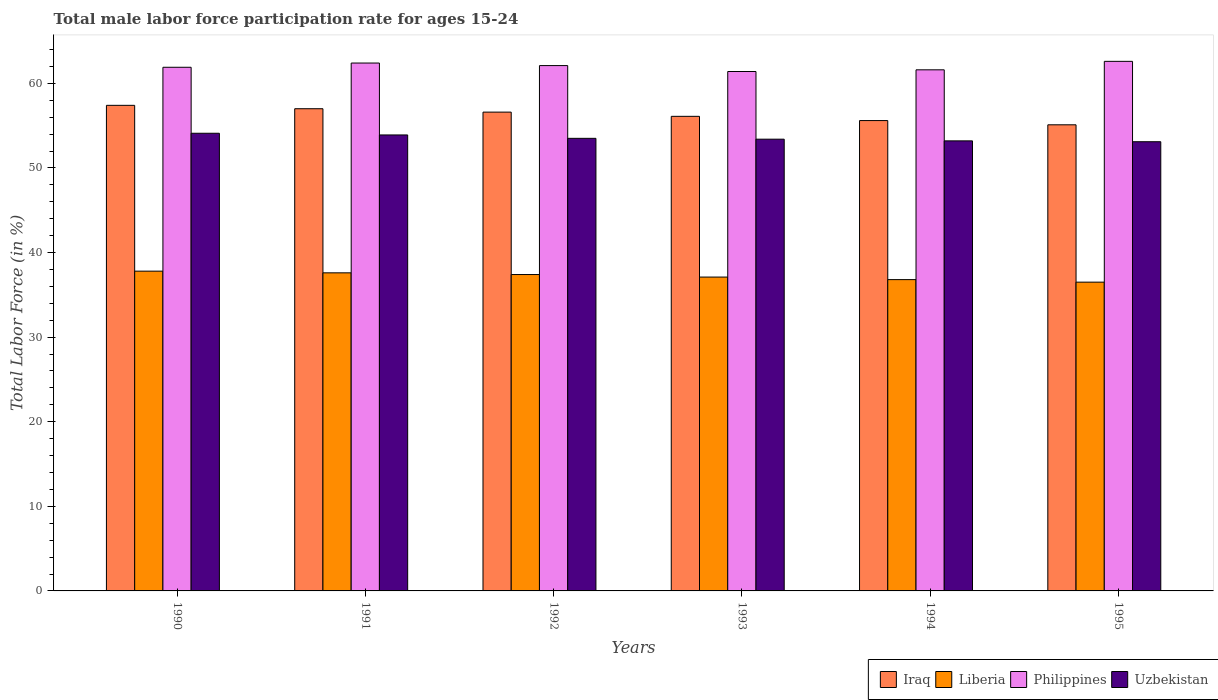How many different coloured bars are there?
Provide a short and direct response. 4. How many groups of bars are there?
Give a very brief answer. 6. Are the number of bars per tick equal to the number of legend labels?
Offer a very short reply. Yes. Are the number of bars on each tick of the X-axis equal?
Ensure brevity in your answer.  Yes. How many bars are there on the 6th tick from the left?
Your answer should be compact. 4. What is the label of the 3rd group of bars from the left?
Provide a succinct answer. 1992. In how many cases, is the number of bars for a given year not equal to the number of legend labels?
Ensure brevity in your answer.  0. Across all years, what is the maximum male labor force participation rate in Philippines?
Your answer should be very brief. 62.6. Across all years, what is the minimum male labor force participation rate in Liberia?
Offer a terse response. 36.5. What is the total male labor force participation rate in Philippines in the graph?
Provide a short and direct response. 372. What is the difference between the male labor force participation rate in Iraq in 1991 and that in 1992?
Provide a succinct answer. 0.4. What is the average male labor force participation rate in Uzbekistan per year?
Your answer should be very brief. 53.53. In the year 1991, what is the difference between the male labor force participation rate in Iraq and male labor force participation rate in Liberia?
Make the answer very short. 19.4. In how many years, is the male labor force participation rate in Uzbekistan greater than 56 %?
Provide a short and direct response. 0. What is the ratio of the male labor force participation rate in Iraq in 1994 to that in 1995?
Keep it short and to the point. 1.01. Is the male labor force participation rate in Iraq in 1990 less than that in 1991?
Provide a short and direct response. No. What is the difference between the highest and the second highest male labor force participation rate in Uzbekistan?
Make the answer very short. 0.2. What is the difference between the highest and the lowest male labor force participation rate in Iraq?
Provide a short and direct response. 2.3. In how many years, is the male labor force participation rate in Uzbekistan greater than the average male labor force participation rate in Uzbekistan taken over all years?
Give a very brief answer. 2. Is it the case that in every year, the sum of the male labor force participation rate in Iraq and male labor force participation rate in Philippines is greater than the sum of male labor force participation rate in Uzbekistan and male labor force participation rate in Liberia?
Provide a succinct answer. Yes. What does the 3rd bar from the left in 1991 represents?
Your answer should be compact. Philippines. What does the 2nd bar from the right in 1995 represents?
Provide a short and direct response. Philippines. How many bars are there?
Offer a very short reply. 24. Are all the bars in the graph horizontal?
Your response must be concise. No. Are the values on the major ticks of Y-axis written in scientific E-notation?
Provide a short and direct response. No. Where does the legend appear in the graph?
Ensure brevity in your answer.  Bottom right. How many legend labels are there?
Offer a terse response. 4. How are the legend labels stacked?
Your response must be concise. Horizontal. What is the title of the graph?
Offer a very short reply. Total male labor force participation rate for ages 15-24. Does "South Africa" appear as one of the legend labels in the graph?
Your response must be concise. No. What is the Total Labor Force (in %) of Iraq in 1990?
Give a very brief answer. 57.4. What is the Total Labor Force (in %) of Liberia in 1990?
Your answer should be very brief. 37.8. What is the Total Labor Force (in %) in Philippines in 1990?
Your answer should be very brief. 61.9. What is the Total Labor Force (in %) of Uzbekistan in 1990?
Make the answer very short. 54.1. What is the Total Labor Force (in %) of Iraq in 1991?
Make the answer very short. 57. What is the Total Labor Force (in %) in Liberia in 1991?
Your answer should be very brief. 37.6. What is the Total Labor Force (in %) in Philippines in 1991?
Make the answer very short. 62.4. What is the Total Labor Force (in %) in Uzbekistan in 1991?
Offer a terse response. 53.9. What is the Total Labor Force (in %) of Iraq in 1992?
Your answer should be very brief. 56.6. What is the Total Labor Force (in %) of Liberia in 1992?
Keep it short and to the point. 37.4. What is the Total Labor Force (in %) in Philippines in 1992?
Provide a short and direct response. 62.1. What is the Total Labor Force (in %) of Uzbekistan in 1992?
Your answer should be compact. 53.5. What is the Total Labor Force (in %) of Iraq in 1993?
Give a very brief answer. 56.1. What is the Total Labor Force (in %) of Liberia in 1993?
Provide a short and direct response. 37.1. What is the Total Labor Force (in %) of Philippines in 1993?
Keep it short and to the point. 61.4. What is the Total Labor Force (in %) in Uzbekistan in 1993?
Your answer should be very brief. 53.4. What is the Total Labor Force (in %) in Iraq in 1994?
Ensure brevity in your answer.  55.6. What is the Total Labor Force (in %) of Liberia in 1994?
Your answer should be compact. 36.8. What is the Total Labor Force (in %) of Philippines in 1994?
Your response must be concise. 61.6. What is the Total Labor Force (in %) of Uzbekistan in 1994?
Ensure brevity in your answer.  53.2. What is the Total Labor Force (in %) in Iraq in 1995?
Provide a short and direct response. 55.1. What is the Total Labor Force (in %) of Liberia in 1995?
Your answer should be compact. 36.5. What is the Total Labor Force (in %) of Philippines in 1995?
Provide a succinct answer. 62.6. What is the Total Labor Force (in %) of Uzbekistan in 1995?
Your answer should be very brief. 53.1. Across all years, what is the maximum Total Labor Force (in %) of Iraq?
Offer a very short reply. 57.4. Across all years, what is the maximum Total Labor Force (in %) in Liberia?
Your answer should be very brief. 37.8. Across all years, what is the maximum Total Labor Force (in %) in Philippines?
Keep it short and to the point. 62.6. Across all years, what is the maximum Total Labor Force (in %) of Uzbekistan?
Your answer should be very brief. 54.1. Across all years, what is the minimum Total Labor Force (in %) in Iraq?
Provide a succinct answer. 55.1. Across all years, what is the minimum Total Labor Force (in %) of Liberia?
Your response must be concise. 36.5. Across all years, what is the minimum Total Labor Force (in %) in Philippines?
Your response must be concise. 61.4. Across all years, what is the minimum Total Labor Force (in %) of Uzbekistan?
Your answer should be compact. 53.1. What is the total Total Labor Force (in %) in Iraq in the graph?
Offer a very short reply. 337.8. What is the total Total Labor Force (in %) of Liberia in the graph?
Ensure brevity in your answer.  223.2. What is the total Total Labor Force (in %) of Philippines in the graph?
Your answer should be very brief. 372. What is the total Total Labor Force (in %) in Uzbekistan in the graph?
Provide a succinct answer. 321.2. What is the difference between the Total Labor Force (in %) in Iraq in 1990 and that in 1991?
Your response must be concise. 0.4. What is the difference between the Total Labor Force (in %) in Iraq in 1990 and that in 1992?
Your answer should be compact. 0.8. What is the difference between the Total Labor Force (in %) in Liberia in 1990 and that in 1992?
Give a very brief answer. 0.4. What is the difference between the Total Labor Force (in %) in Iraq in 1990 and that in 1993?
Your response must be concise. 1.3. What is the difference between the Total Labor Force (in %) in Liberia in 1990 and that in 1993?
Provide a succinct answer. 0.7. What is the difference between the Total Labor Force (in %) of Iraq in 1990 and that in 1994?
Offer a very short reply. 1.8. What is the difference between the Total Labor Force (in %) in Philippines in 1990 and that in 1994?
Provide a succinct answer. 0.3. What is the difference between the Total Labor Force (in %) in Uzbekistan in 1990 and that in 1994?
Your answer should be compact. 0.9. What is the difference between the Total Labor Force (in %) in Liberia in 1990 and that in 1995?
Provide a succinct answer. 1.3. What is the difference between the Total Labor Force (in %) of Uzbekistan in 1990 and that in 1995?
Your response must be concise. 1. What is the difference between the Total Labor Force (in %) in Iraq in 1991 and that in 1992?
Provide a succinct answer. 0.4. What is the difference between the Total Labor Force (in %) of Philippines in 1991 and that in 1992?
Give a very brief answer. 0.3. What is the difference between the Total Labor Force (in %) of Uzbekistan in 1991 and that in 1992?
Your answer should be compact. 0.4. What is the difference between the Total Labor Force (in %) in Iraq in 1991 and that in 1993?
Your answer should be compact. 0.9. What is the difference between the Total Labor Force (in %) in Philippines in 1991 and that in 1993?
Offer a terse response. 1. What is the difference between the Total Labor Force (in %) of Uzbekistan in 1991 and that in 1993?
Give a very brief answer. 0.5. What is the difference between the Total Labor Force (in %) of Liberia in 1991 and that in 1994?
Make the answer very short. 0.8. What is the difference between the Total Labor Force (in %) in Philippines in 1991 and that in 1994?
Offer a very short reply. 0.8. What is the difference between the Total Labor Force (in %) of Iraq in 1991 and that in 1995?
Keep it short and to the point. 1.9. What is the difference between the Total Labor Force (in %) in Philippines in 1991 and that in 1995?
Your answer should be very brief. -0.2. What is the difference between the Total Labor Force (in %) in Uzbekistan in 1991 and that in 1995?
Offer a terse response. 0.8. What is the difference between the Total Labor Force (in %) of Iraq in 1992 and that in 1993?
Provide a short and direct response. 0.5. What is the difference between the Total Labor Force (in %) in Liberia in 1992 and that in 1993?
Provide a succinct answer. 0.3. What is the difference between the Total Labor Force (in %) of Philippines in 1992 and that in 1993?
Ensure brevity in your answer.  0.7. What is the difference between the Total Labor Force (in %) of Liberia in 1992 and that in 1994?
Ensure brevity in your answer.  0.6. What is the difference between the Total Labor Force (in %) of Philippines in 1992 and that in 1994?
Your response must be concise. 0.5. What is the difference between the Total Labor Force (in %) in Uzbekistan in 1992 and that in 1994?
Provide a succinct answer. 0.3. What is the difference between the Total Labor Force (in %) in Iraq in 1992 and that in 1995?
Your answer should be compact. 1.5. What is the difference between the Total Labor Force (in %) in Philippines in 1992 and that in 1995?
Offer a terse response. -0.5. What is the difference between the Total Labor Force (in %) of Uzbekistan in 1992 and that in 1995?
Your response must be concise. 0.4. What is the difference between the Total Labor Force (in %) of Liberia in 1993 and that in 1994?
Your answer should be compact. 0.3. What is the difference between the Total Labor Force (in %) in Philippines in 1993 and that in 1994?
Your answer should be compact. -0.2. What is the difference between the Total Labor Force (in %) of Liberia in 1993 and that in 1995?
Offer a terse response. 0.6. What is the difference between the Total Labor Force (in %) of Uzbekistan in 1993 and that in 1995?
Make the answer very short. 0.3. What is the difference between the Total Labor Force (in %) of Liberia in 1994 and that in 1995?
Give a very brief answer. 0.3. What is the difference between the Total Labor Force (in %) of Uzbekistan in 1994 and that in 1995?
Offer a terse response. 0.1. What is the difference between the Total Labor Force (in %) of Iraq in 1990 and the Total Labor Force (in %) of Liberia in 1991?
Keep it short and to the point. 19.8. What is the difference between the Total Labor Force (in %) of Iraq in 1990 and the Total Labor Force (in %) of Uzbekistan in 1991?
Ensure brevity in your answer.  3.5. What is the difference between the Total Labor Force (in %) in Liberia in 1990 and the Total Labor Force (in %) in Philippines in 1991?
Ensure brevity in your answer.  -24.6. What is the difference between the Total Labor Force (in %) in Liberia in 1990 and the Total Labor Force (in %) in Uzbekistan in 1991?
Your answer should be very brief. -16.1. What is the difference between the Total Labor Force (in %) of Iraq in 1990 and the Total Labor Force (in %) of Liberia in 1992?
Provide a short and direct response. 20. What is the difference between the Total Labor Force (in %) in Iraq in 1990 and the Total Labor Force (in %) in Uzbekistan in 1992?
Make the answer very short. 3.9. What is the difference between the Total Labor Force (in %) of Liberia in 1990 and the Total Labor Force (in %) of Philippines in 1992?
Give a very brief answer. -24.3. What is the difference between the Total Labor Force (in %) of Liberia in 1990 and the Total Labor Force (in %) of Uzbekistan in 1992?
Make the answer very short. -15.7. What is the difference between the Total Labor Force (in %) of Philippines in 1990 and the Total Labor Force (in %) of Uzbekistan in 1992?
Offer a very short reply. 8.4. What is the difference between the Total Labor Force (in %) of Iraq in 1990 and the Total Labor Force (in %) of Liberia in 1993?
Provide a short and direct response. 20.3. What is the difference between the Total Labor Force (in %) in Iraq in 1990 and the Total Labor Force (in %) in Philippines in 1993?
Make the answer very short. -4. What is the difference between the Total Labor Force (in %) in Iraq in 1990 and the Total Labor Force (in %) in Uzbekistan in 1993?
Your answer should be compact. 4. What is the difference between the Total Labor Force (in %) in Liberia in 1990 and the Total Labor Force (in %) in Philippines in 1993?
Your answer should be compact. -23.6. What is the difference between the Total Labor Force (in %) of Liberia in 1990 and the Total Labor Force (in %) of Uzbekistan in 1993?
Offer a very short reply. -15.6. What is the difference between the Total Labor Force (in %) of Iraq in 1990 and the Total Labor Force (in %) of Liberia in 1994?
Your answer should be very brief. 20.6. What is the difference between the Total Labor Force (in %) in Liberia in 1990 and the Total Labor Force (in %) in Philippines in 1994?
Your answer should be compact. -23.8. What is the difference between the Total Labor Force (in %) of Liberia in 1990 and the Total Labor Force (in %) of Uzbekistan in 1994?
Make the answer very short. -15.4. What is the difference between the Total Labor Force (in %) in Philippines in 1990 and the Total Labor Force (in %) in Uzbekistan in 1994?
Give a very brief answer. 8.7. What is the difference between the Total Labor Force (in %) of Iraq in 1990 and the Total Labor Force (in %) of Liberia in 1995?
Your answer should be compact. 20.9. What is the difference between the Total Labor Force (in %) in Liberia in 1990 and the Total Labor Force (in %) in Philippines in 1995?
Ensure brevity in your answer.  -24.8. What is the difference between the Total Labor Force (in %) of Liberia in 1990 and the Total Labor Force (in %) of Uzbekistan in 1995?
Keep it short and to the point. -15.3. What is the difference between the Total Labor Force (in %) in Philippines in 1990 and the Total Labor Force (in %) in Uzbekistan in 1995?
Keep it short and to the point. 8.8. What is the difference between the Total Labor Force (in %) in Iraq in 1991 and the Total Labor Force (in %) in Liberia in 1992?
Your answer should be compact. 19.6. What is the difference between the Total Labor Force (in %) of Iraq in 1991 and the Total Labor Force (in %) of Philippines in 1992?
Your answer should be very brief. -5.1. What is the difference between the Total Labor Force (in %) of Iraq in 1991 and the Total Labor Force (in %) of Uzbekistan in 1992?
Provide a succinct answer. 3.5. What is the difference between the Total Labor Force (in %) in Liberia in 1991 and the Total Labor Force (in %) in Philippines in 1992?
Ensure brevity in your answer.  -24.5. What is the difference between the Total Labor Force (in %) in Liberia in 1991 and the Total Labor Force (in %) in Uzbekistan in 1992?
Your response must be concise. -15.9. What is the difference between the Total Labor Force (in %) in Philippines in 1991 and the Total Labor Force (in %) in Uzbekistan in 1992?
Offer a terse response. 8.9. What is the difference between the Total Labor Force (in %) of Iraq in 1991 and the Total Labor Force (in %) of Philippines in 1993?
Provide a succinct answer. -4.4. What is the difference between the Total Labor Force (in %) in Iraq in 1991 and the Total Labor Force (in %) in Uzbekistan in 1993?
Make the answer very short. 3.6. What is the difference between the Total Labor Force (in %) of Liberia in 1991 and the Total Labor Force (in %) of Philippines in 1993?
Your answer should be very brief. -23.8. What is the difference between the Total Labor Force (in %) of Liberia in 1991 and the Total Labor Force (in %) of Uzbekistan in 1993?
Provide a succinct answer. -15.8. What is the difference between the Total Labor Force (in %) in Philippines in 1991 and the Total Labor Force (in %) in Uzbekistan in 1993?
Your answer should be compact. 9. What is the difference between the Total Labor Force (in %) in Iraq in 1991 and the Total Labor Force (in %) in Liberia in 1994?
Give a very brief answer. 20.2. What is the difference between the Total Labor Force (in %) in Liberia in 1991 and the Total Labor Force (in %) in Philippines in 1994?
Ensure brevity in your answer.  -24. What is the difference between the Total Labor Force (in %) of Liberia in 1991 and the Total Labor Force (in %) of Uzbekistan in 1994?
Your response must be concise. -15.6. What is the difference between the Total Labor Force (in %) of Philippines in 1991 and the Total Labor Force (in %) of Uzbekistan in 1994?
Make the answer very short. 9.2. What is the difference between the Total Labor Force (in %) of Iraq in 1991 and the Total Labor Force (in %) of Liberia in 1995?
Provide a succinct answer. 20.5. What is the difference between the Total Labor Force (in %) in Iraq in 1991 and the Total Labor Force (in %) in Philippines in 1995?
Provide a succinct answer. -5.6. What is the difference between the Total Labor Force (in %) of Liberia in 1991 and the Total Labor Force (in %) of Philippines in 1995?
Make the answer very short. -25. What is the difference between the Total Labor Force (in %) in Liberia in 1991 and the Total Labor Force (in %) in Uzbekistan in 1995?
Your response must be concise. -15.5. What is the difference between the Total Labor Force (in %) in Iraq in 1992 and the Total Labor Force (in %) in Liberia in 1993?
Ensure brevity in your answer.  19.5. What is the difference between the Total Labor Force (in %) in Iraq in 1992 and the Total Labor Force (in %) in Philippines in 1993?
Ensure brevity in your answer.  -4.8. What is the difference between the Total Labor Force (in %) of Liberia in 1992 and the Total Labor Force (in %) of Philippines in 1993?
Provide a short and direct response. -24. What is the difference between the Total Labor Force (in %) of Liberia in 1992 and the Total Labor Force (in %) of Uzbekistan in 1993?
Offer a terse response. -16. What is the difference between the Total Labor Force (in %) of Iraq in 1992 and the Total Labor Force (in %) of Liberia in 1994?
Ensure brevity in your answer.  19.8. What is the difference between the Total Labor Force (in %) in Iraq in 1992 and the Total Labor Force (in %) in Uzbekistan in 1994?
Keep it short and to the point. 3.4. What is the difference between the Total Labor Force (in %) in Liberia in 1992 and the Total Labor Force (in %) in Philippines in 1994?
Make the answer very short. -24.2. What is the difference between the Total Labor Force (in %) of Liberia in 1992 and the Total Labor Force (in %) of Uzbekistan in 1994?
Provide a short and direct response. -15.8. What is the difference between the Total Labor Force (in %) in Iraq in 1992 and the Total Labor Force (in %) in Liberia in 1995?
Your response must be concise. 20.1. What is the difference between the Total Labor Force (in %) in Iraq in 1992 and the Total Labor Force (in %) in Philippines in 1995?
Provide a succinct answer. -6. What is the difference between the Total Labor Force (in %) of Iraq in 1992 and the Total Labor Force (in %) of Uzbekistan in 1995?
Provide a succinct answer. 3.5. What is the difference between the Total Labor Force (in %) in Liberia in 1992 and the Total Labor Force (in %) in Philippines in 1995?
Your answer should be very brief. -25.2. What is the difference between the Total Labor Force (in %) in Liberia in 1992 and the Total Labor Force (in %) in Uzbekistan in 1995?
Offer a very short reply. -15.7. What is the difference between the Total Labor Force (in %) in Iraq in 1993 and the Total Labor Force (in %) in Liberia in 1994?
Offer a terse response. 19.3. What is the difference between the Total Labor Force (in %) of Iraq in 1993 and the Total Labor Force (in %) of Philippines in 1994?
Keep it short and to the point. -5.5. What is the difference between the Total Labor Force (in %) of Liberia in 1993 and the Total Labor Force (in %) of Philippines in 1994?
Offer a terse response. -24.5. What is the difference between the Total Labor Force (in %) in Liberia in 1993 and the Total Labor Force (in %) in Uzbekistan in 1994?
Your answer should be compact. -16.1. What is the difference between the Total Labor Force (in %) in Philippines in 1993 and the Total Labor Force (in %) in Uzbekistan in 1994?
Your answer should be very brief. 8.2. What is the difference between the Total Labor Force (in %) in Iraq in 1993 and the Total Labor Force (in %) in Liberia in 1995?
Your answer should be very brief. 19.6. What is the difference between the Total Labor Force (in %) of Liberia in 1993 and the Total Labor Force (in %) of Philippines in 1995?
Your answer should be very brief. -25.5. What is the difference between the Total Labor Force (in %) of Iraq in 1994 and the Total Labor Force (in %) of Liberia in 1995?
Provide a succinct answer. 19.1. What is the difference between the Total Labor Force (in %) of Liberia in 1994 and the Total Labor Force (in %) of Philippines in 1995?
Keep it short and to the point. -25.8. What is the difference between the Total Labor Force (in %) of Liberia in 1994 and the Total Labor Force (in %) of Uzbekistan in 1995?
Your response must be concise. -16.3. What is the difference between the Total Labor Force (in %) in Philippines in 1994 and the Total Labor Force (in %) in Uzbekistan in 1995?
Ensure brevity in your answer.  8.5. What is the average Total Labor Force (in %) in Iraq per year?
Give a very brief answer. 56.3. What is the average Total Labor Force (in %) of Liberia per year?
Your response must be concise. 37.2. What is the average Total Labor Force (in %) of Uzbekistan per year?
Offer a terse response. 53.53. In the year 1990, what is the difference between the Total Labor Force (in %) in Iraq and Total Labor Force (in %) in Liberia?
Keep it short and to the point. 19.6. In the year 1990, what is the difference between the Total Labor Force (in %) of Iraq and Total Labor Force (in %) of Uzbekistan?
Keep it short and to the point. 3.3. In the year 1990, what is the difference between the Total Labor Force (in %) in Liberia and Total Labor Force (in %) in Philippines?
Your response must be concise. -24.1. In the year 1990, what is the difference between the Total Labor Force (in %) in Liberia and Total Labor Force (in %) in Uzbekistan?
Keep it short and to the point. -16.3. In the year 1990, what is the difference between the Total Labor Force (in %) in Philippines and Total Labor Force (in %) in Uzbekistan?
Offer a terse response. 7.8. In the year 1991, what is the difference between the Total Labor Force (in %) in Iraq and Total Labor Force (in %) in Philippines?
Make the answer very short. -5.4. In the year 1991, what is the difference between the Total Labor Force (in %) of Iraq and Total Labor Force (in %) of Uzbekistan?
Make the answer very short. 3.1. In the year 1991, what is the difference between the Total Labor Force (in %) in Liberia and Total Labor Force (in %) in Philippines?
Offer a terse response. -24.8. In the year 1991, what is the difference between the Total Labor Force (in %) in Liberia and Total Labor Force (in %) in Uzbekistan?
Make the answer very short. -16.3. In the year 1991, what is the difference between the Total Labor Force (in %) of Philippines and Total Labor Force (in %) of Uzbekistan?
Your answer should be very brief. 8.5. In the year 1992, what is the difference between the Total Labor Force (in %) in Iraq and Total Labor Force (in %) in Philippines?
Make the answer very short. -5.5. In the year 1992, what is the difference between the Total Labor Force (in %) in Liberia and Total Labor Force (in %) in Philippines?
Offer a very short reply. -24.7. In the year 1992, what is the difference between the Total Labor Force (in %) of Liberia and Total Labor Force (in %) of Uzbekistan?
Ensure brevity in your answer.  -16.1. In the year 1992, what is the difference between the Total Labor Force (in %) of Philippines and Total Labor Force (in %) of Uzbekistan?
Provide a succinct answer. 8.6. In the year 1993, what is the difference between the Total Labor Force (in %) of Iraq and Total Labor Force (in %) of Liberia?
Ensure brevity in your answer.  19. In the year 1993, what is the difference between the Total Labor Force (in %) of Iraq and Total Labor Force (in %) of Uzbekistan?
Provide a short and direct response. 2.7. In the year 1993, what is the difference between the Total Labor Force (in %) in Liberia and Total Labor Force (in %) in Philippines?
Your answer should be compact. -24.3. In the year 1993, what is the difference between the Total Labor Force (in %) in Liberia and Total Labor Force (in %) in Uzbekistan?
Offer a terse response. -16.3. In the year 1993, what is the difference between the Total Labor Force (in %) of Philippines and Total Labor Force (in %) of Uzbekistan?
Provide a succinct answer. 8. In the year 1994, what is the difference between the Total Labor Force (in %) of Iraq and Total Labor Force (in %) of Philippines?
Ensure brevity in your answer.  -6. In the year 1994, what is the difference between the Total Labor Force (in %) of Iraq and Total Labor Force (in %) of Uzbekistan?
Provide a succinct answer. 2.4. In the year 1994, what is the difference between the Total Labor Force (in %) of Liberia and Total Labor Force (in %) of Philippines?
Give a very brief answer. -24.8. In the year 1994, what is the difference between the Total Labor Force (in %) in Liberia and Total Labor Force (in %) in Uzbekistan?
Keep it short and to the point. -16.4. In the year 1994, what is the difference between the Total Labor Force (in %) of Philippines and Total Labor Force (in %) of Uzbekistan?
Provide a short and direct response. 8.4. In the year 1995, what is the difference between the Total Labor Force (in %) in Iraq and Total Labor Force (in %) in Liberia?
Your response must be concise. 18.6. In the year 1995, what is the difference between the Total Labor Force (in %) of Liberia and Total Labor Force (in %) of Philippines?
Ensure brevity in your answer.  -26.1. In the year 1995, what is the difference between the Total Labor Force (in %) of Liberia and Total Labor Force (in %) of Uzbekistan?
Keep it short and to the point. -16.6. In the year 1995, what is the difference between the Total Labor Force (in %) in Philippines and Total Labor Force (in %) in Uzbekistan?
Provide a short and direct response. 9.5. What is the ratio of the Total Labor Force (in %) in Liberia in 1990 to that in 1991?
Offer a very short reply. 1.01. What is the ratio of the Total Labor Force (in %) in Iraq in 1990 to that in 1992?
Give a very brief answer. 1.01. What is the ratio of the Total Labor Force (in %) of Liberia in 1990 to that in 1992?
Offer a very short reply. 1.01. What is the ratio of the Total Labor Force (in %) in Philippines in 1990 to that in 1992?
Offer a terse response. 1. What is the ratio of the Total Labor Force (in %) of Uzbekistan in 1990 to that in 1992?
Keep it short and to the point. 1.01. What is the ratio of the Total Labor Force (in %) in Iraq in 1990 to that in 1993?
Offer a very short reply. 1.02. What is the ratio of the Total Labor Force (in %) of Liberia in 1990 to that in 1993?
Offer a very short reply. 1.02. What is the ratio of the Total Labor Force (in %) of Philippines in 1990 to that in 1993?
Ensure brevity in your answer.  1.01. What is the ratio of the Total Labor Force (in %) in Uzbekistan in 1990 to that in 1993?
Give a very brief answer. 1.01. What is the ratio of the Total Labor Force (in %) in Iraq in 1990 to that in 1994?
Give a very brief answer. 1.03. What is the ratio of the Total Labor Force (in %) of Liberia in 1990 to that in 1994?
Ensure brevity in your answer.  1.03. What is the ratio of the Total Labor Force (in %) of Philippines in 1990 to that in 1994?
Keep it short and to the point. 1. What is the ratio of the Total Labor Force (in %) of Uzbekistan in 1990 to that in 1994?
Provide a succinct answer. 1.02. What is the ratio of the Total Labor Force (in %) in Iraq in 1990 to that in 1995?
Ensure brevity in your answer.  1.04. What is the ratio of the Total Labor Force (in %) in Liberia in 1990 to that in 1995?
Your answer should be very brief. 1.04. What is the ratio of the Total Labor Force (in %) of Philippines in 1990 to that in 1995?
Your answer should be compact. 0.99. What is the ratio of the Total Labor Force (in %) of Uzbekistan in 1990 to that in 1995?
Provide a succinct answer. 1.02. What is the ratio of the Total Labor Force (in %) of Iraq in 1991 to that in 1992?
Offer a terse response. 1.01. What is the ratio of the Total Labor Force (in %) in Philippines in 1991 to that in 1992?
Your response must be concise. 1. What is the ratio of the Total Labor Force (in %) in Uzbekistan in 1991 to that in 1992?
Give a very brief answer. 1.01. What is the ratio of the Total Labor Force (in %) in Iraq in 1991 to that in 1993?
Offer a very short reply. 1.02. What is the ratio of the Total Labor Force (in %) in Liberia in 1991 to that in 1993?
Your answer should be very brief. 1.01. What is the ratio of the Total Labor Force (in %) in Philippines in 1991 to that in 1993?
Your answer should be very brief. 1.02. What is the ratio of the Total Labor Force (in %) of Uzbekistan in 1991 to that in 1993?
Offer a terse response. 1.01. What is the ratio of the Total Labor Force (in %) of Iraq in 1991 to that in 1994?
Provide a succinct answer. 1.03. What is the ratio of the Total Labor Force (in %) in Liberia in 1991 to that in 1994?
Offer a very short reply. 1.02. What is the ratio of the Total Labor Force (in %) of Philippines in 1991 to that in 1994?
Provide a succinct answer. 1.01. What is the ratio of the Total Labor Force (in %) of Uzbekistan in 1991 to that in 1994?
Your answer should be very brief. 1.01. What is the ratio of the Total Labor Force (in %) of Iraq in 1991 to that in 1995?
Your answer should be very brief. 1.03. What is the ratio of the Total Labor Force (in %) in Liberia in 1991 to that in 1995?
Keep it short and to the point. 1.03. What is the ratio of the Total Labor Force (in %) of Philippines in 1991 to that in 1995?
Keep it short and to the point. 1. What is the ratio of the Total Labor Force (in %) in Uzbekistan in 1991 to that in 1995?
Your answer should be very brief. 1.02. What is the ratio of the Total Labor Force (in %) in Iraq in 1992 to that in 1993?
Provide a succinct answer. 1.01. What is the ratio of the Total Labor Force (in %) in Philippines in 1992 to that in 1993?
Offer a terse response. 1.01. What is the ratio of the Total Labor Force (in %) in Liberia in 1992 to that in 1994?
Offer a terse response. 1.02. What is the ratio of the Total Labor Force (in %) of Uzbekistan in 1992 to that in 1994?
Your answer should be very brief. 1.01. What is the ratio of the Total Labor Force (in %) of Iraq in 1992 to that in 1995?
Your answer should be very brief. 1.03. What is the ratio of the Total Labor Force (in %) of Liberia in 1992 to that in 1995?
Keep it short and to the point. 1.02. What is the ratio of the Total Labor Force (in %) of Philippines in 1992 to that in 1995?
Your response must be concise. 0.99. What is the ratio of the Total Labor Force (in %) in Uzbekistan in 1992 to that in 1995?
Offer a terse response. 1.01. What is the ratio of the Total Labor Force (in %) of Liberia in 1993 to that in 1994?
Give a very brief answer. 1.01. What is the ratio of the Total Labor Force (in %) of Philippines in 1993 to that in 1994?
Your answer should be very brief. 1. What is the ratio of the Total Labor Force (in %) in Iraq in 1993 to that in 1995?
Keep it short and to the point. 1.02. What is the ratio of the Total Labor Force (in %) in Liberia in 1993 to that in 1995?
Offer a terse response. 1.02. What is the ratio of the Total Labor Force (in %) of Philippines in 1993 to that in 1995?
Ensure brevity in your answer.  0.98. What is the ratio of the Total Labor Force (in %) in Uzbekistan in 1993 to that in 1995?
Offer a very short reply. 1.01. What is the ratio of the Total Labor Force (in %) of Iraq in 1994 to that in 1995?
Your answer should be compact. 1.01. What is the ratio of the Total Labor Force (in %) in Liberia in 1994 to that in 1995?
Your answer should be very brief. 1.01. What is the ratio of the Total Labor Force (in %) in Uzbekistan in 1994 to that in 1995?
Keep it short and to the point. 1. What is the difference between the highest and the second highest Total Labor Force (in %) of Iraq?
Keep it short and to the point. 0.4. What is the difference between the highest and the second highest Total Labor Force (in %) of Uzbekistan?
Your response must be concise. 0.2. 